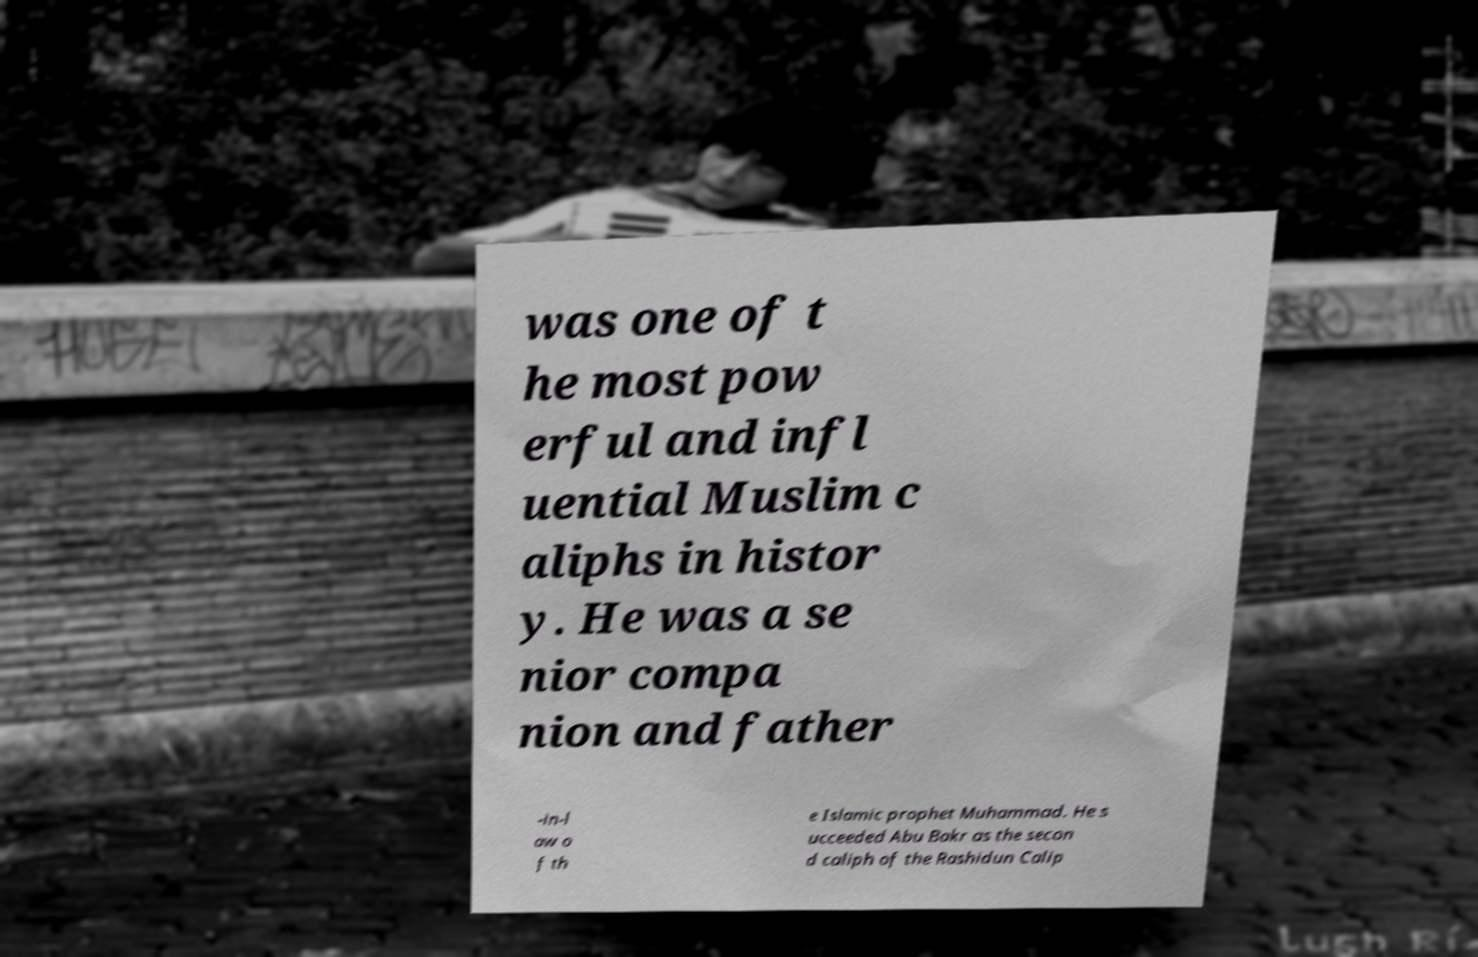There's text embedded in this image that I need extracted. Can you transcribe it verbatim? was one of t he most pow erful and infl uential Muslim c aliphs in histor y. He was a se nior compa nion and father -in-l aw o f th e Islamic prophet Muhammad. He s ucceeded Abu Bakr as the secon d caliph of the Rashidun Calip 